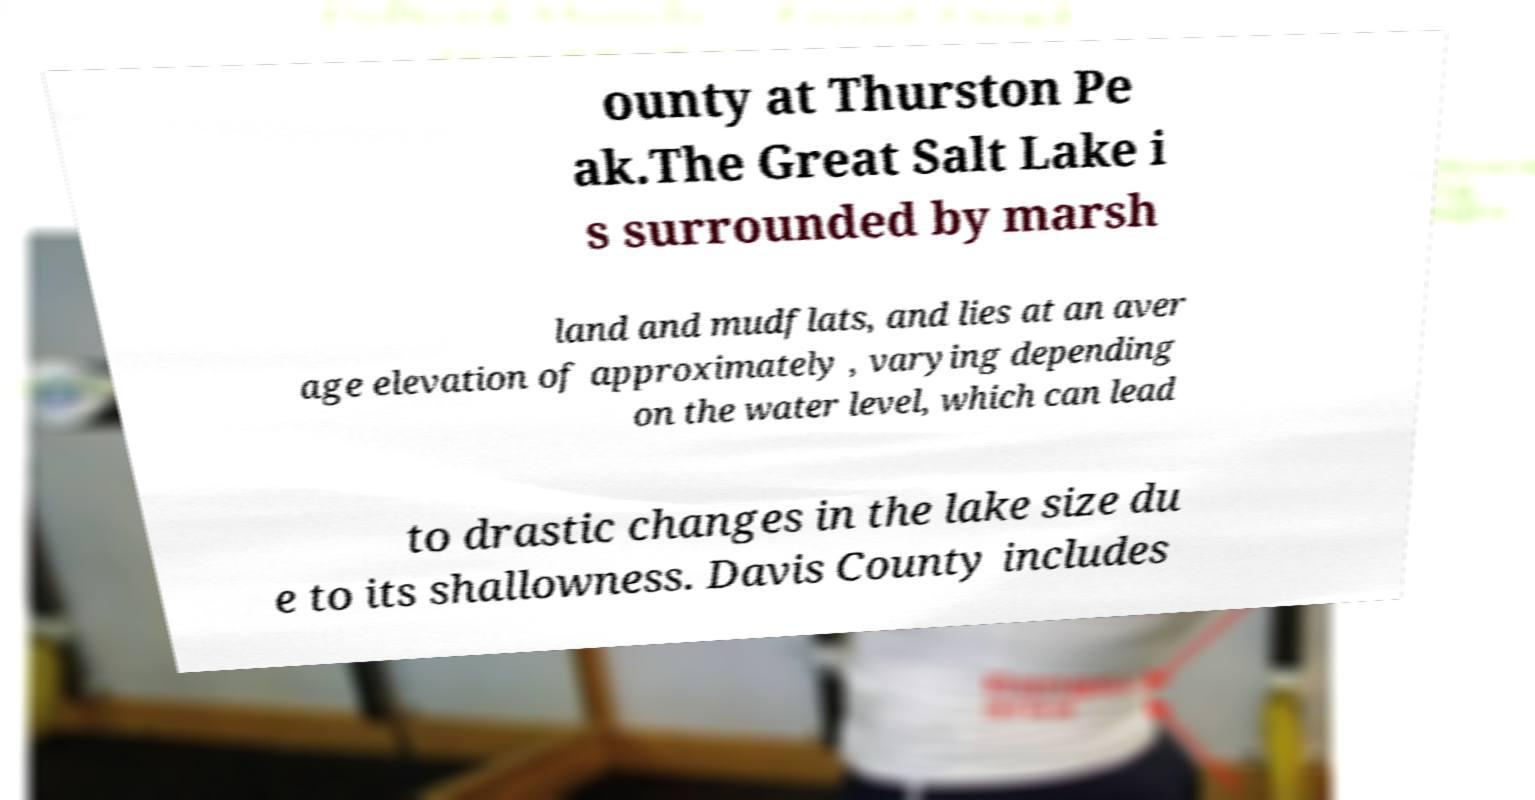I need the written content from this picture converted into text. Can you do that? ounty at Thurston Pe ak.The Great Salt Lake i s surrounded by marsh land and mudflats, and lies at an aver age elevation of approximately , varying depending on the water level, which can lead to drastic changes in the lake size du e to its shallowness. Davis County includes 